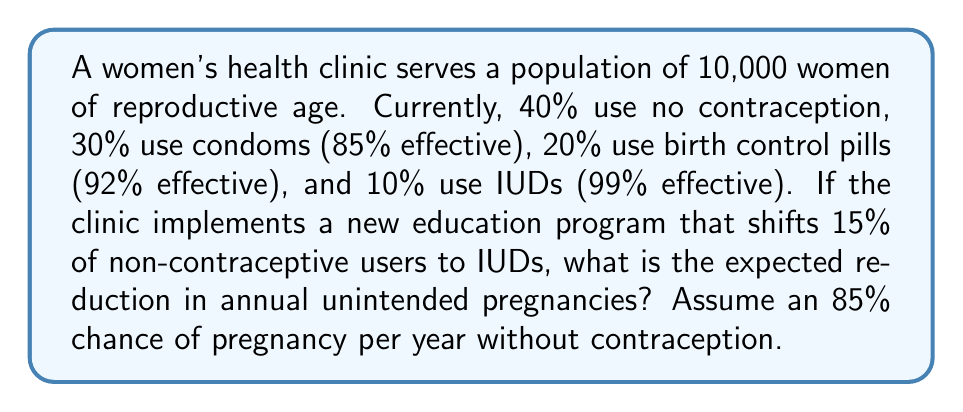Teach me how to tackle this problem. Let's approach this step-by-step:

1) First, calculate the current number of expected pregnancies:
   - No contraception: $0.40 \times 10000 \times 0.85 = 3400$
   - Condoms: $0.30 \times 10000 \times (1 - 0.85) \times 0.85 = 382.5$
   - Pills: $0.20 \times 10000 \times (1 - 0.92) \times 0.85 = 136$
   - IUDs: $0.10 \times 10000 \times (1 - 0.99) \times 0.85 = 8.5$
   Total: $3400 + 382.5 + 136 + 8.5 = 3927$ pregnancies

2) After the program:
   - 15% of 40% (non-contraceptive users) shift to IUDs
   - New percentages: 25% no contraception, 30% condoms, 20% pills, 25% IUDs

3) Calculate the new number of expected pregnancies:
   - No contraception: $0.25 \times 10000 \times 0.85 = 2125$
   - Condoms: $0.30 \times 10000 \times (1 - 0.85) \times 0.85 = 382.5$
   - Pills: $0.20 \times 10000 \times (1 - 0.92) \times 0.85 = 136$
   - IUDs: $0.25 \times 10000 \times (1 - 0.99) \times 0.85 = 21.25$
   Total: $2125 + 382.5 + 136 + 21.25 = 2664.75$ pregnancies

4) Calculate the reduction:
   $3927 - 2664.75 = 1262.25$

Therefore, the expected reduction in annual unintended pregnancies is approximately 1262.
Answer: 1262 pregnancies 